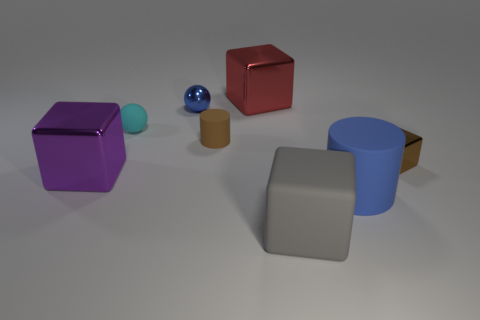Is there a metal object of the same color as the big matte cylinder?
Offer a very short reply. Yes. How many other objects are the same size as the gray rubber cube?
Offer a terse response. 3. There is a big metal object that is left of the brown thing left of the large gray matte object; is there a blue thing that is behind it?
Offer a very short reply. Yes. The purple shiny block is what size?
Your answer should be compact. Large. There is a metal cube that is right of the large red shiny block; what is its size?
Offer a very short reply. Small. There is a blue thing behind the brown matte cylinder; does it have the same size as the big purple shiny block?
Your answer should be very brief. No. Is there anything else of the same color as the big rubber cube?
Keep it short and to the point. No. What shape is the cyan matte thing?
Give a very brief answer. Sphere. What number of metal things are both left of the small blue object and on the right side of the purple thing?
Make the answer very short. 0. Is the big matte cube the same color as the metallic sphere?
Make the answer very short. No. 